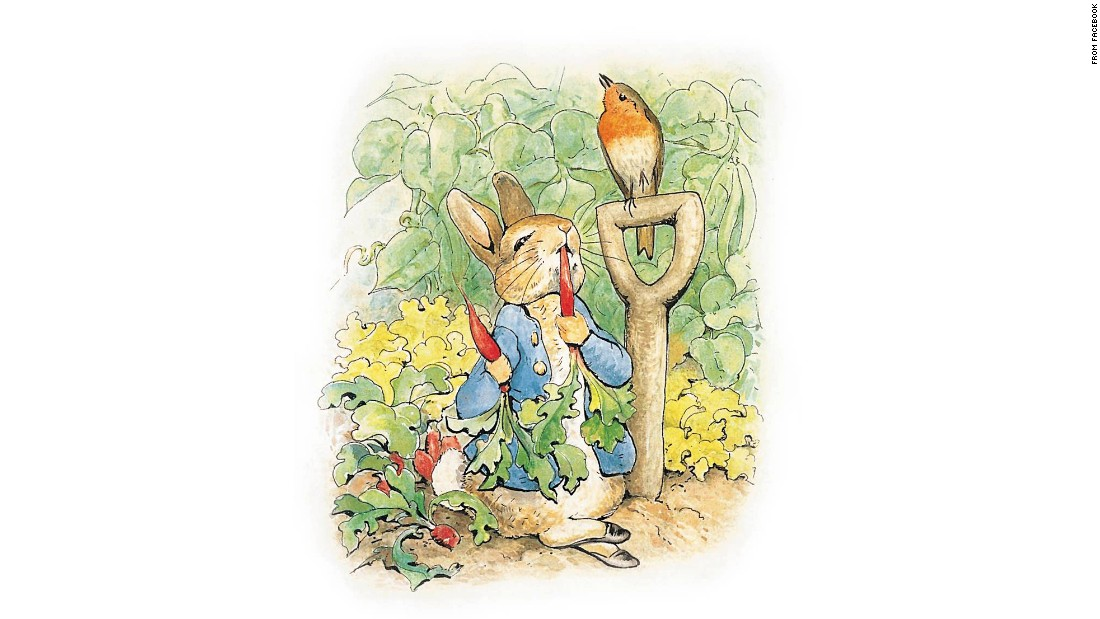Describe the types of vegetables seen in this garden and their growth stages. In the garden, one can spot mature radishes ripe enough for harvesting, indicated by their bright red bulbs peeking through the soil. There are also flourishing green peas, climbing up the support, showing healthy, plump pods, and leafy greens which might include kale or lettuce, displaying lush and ample leaves. 